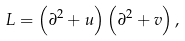<formula> <loc_0><loc_0><loc_500><loc_500>L = \left ( \partial ^ { 2 } + u \right ) \left ( \partial ^ { 2 } + v \right ) ,</formula> 